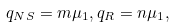Convert formula to latex. <formula><loc_0><loc_0><loc_500><loc_500>q _ { N S } = m \mu _ { 1 } , q _ { R } = n \mu _ { 1 } ,</formula> 